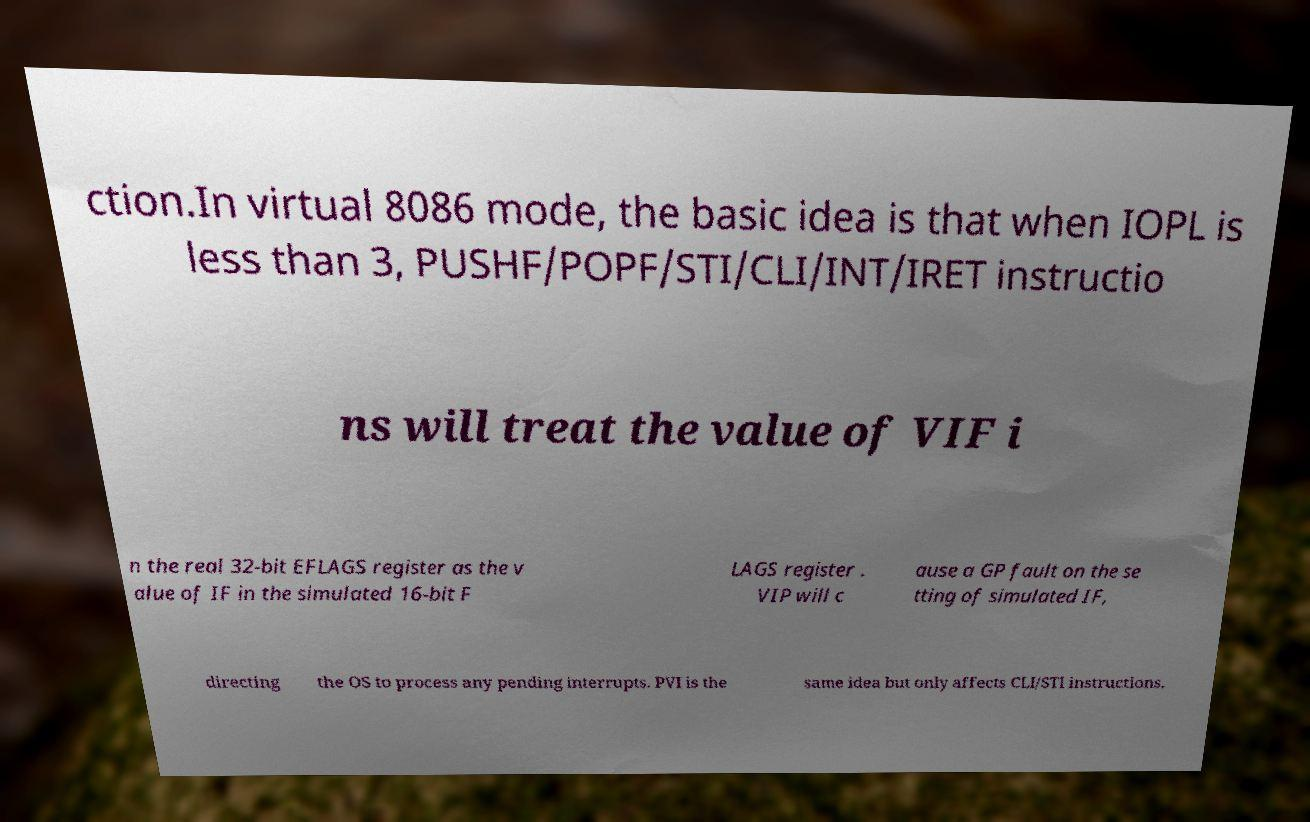Please identify and transcribe the text found in this image. ction.In virtual 8086 mode, the basic idea is that when IOPL is less than 3, PUSHF/POPF/STI/CLI/INT/IRET instructio ns will treat the value of VIF i n the real 32-bit EFLAGS register as the v alue of IF in the simulated 16-bit F LAGS register . VIP will c ause a GP fault on the se tting of simulated IF, directing the OS to process any pending interrupts. PVI is the same idea but only affects CLI/STI instructions. 